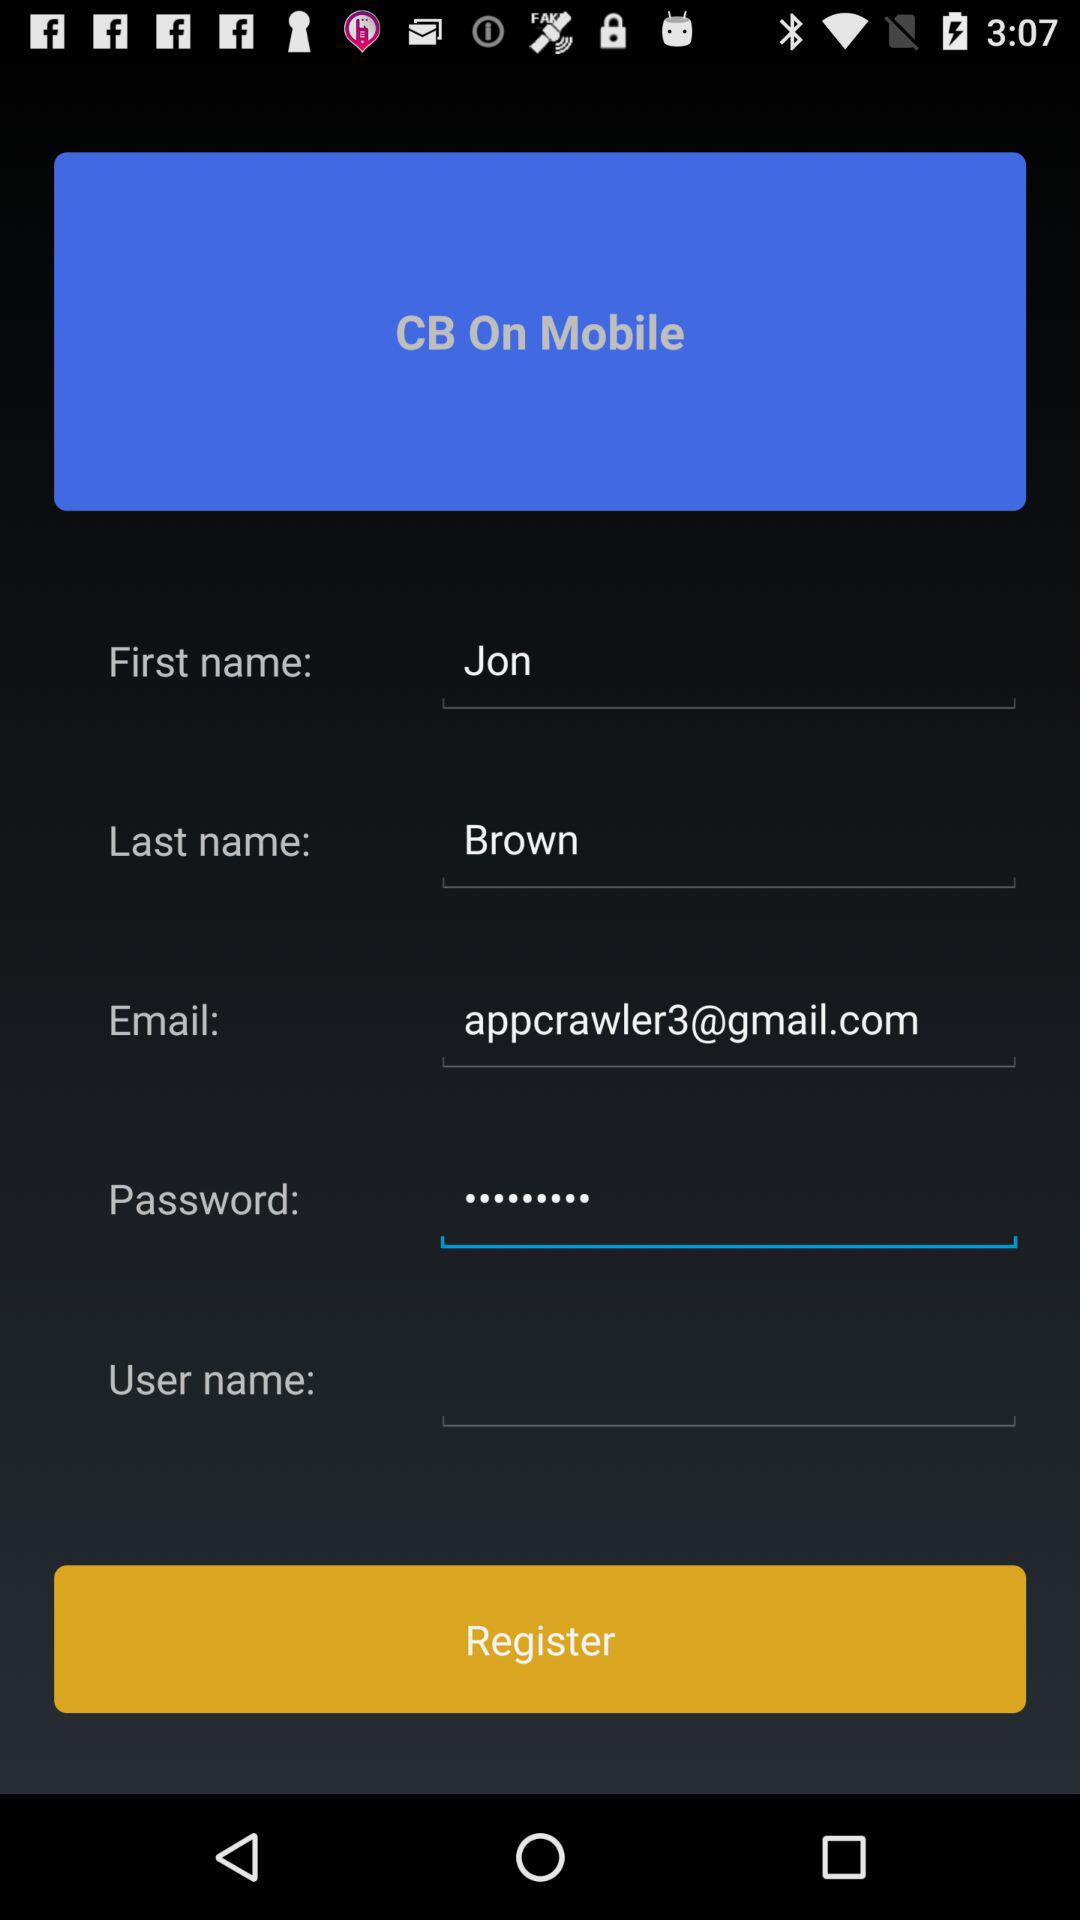What is Jon Brown's phone number?
When the provided information is insufficient, respond with <no answer>. <no answer> 